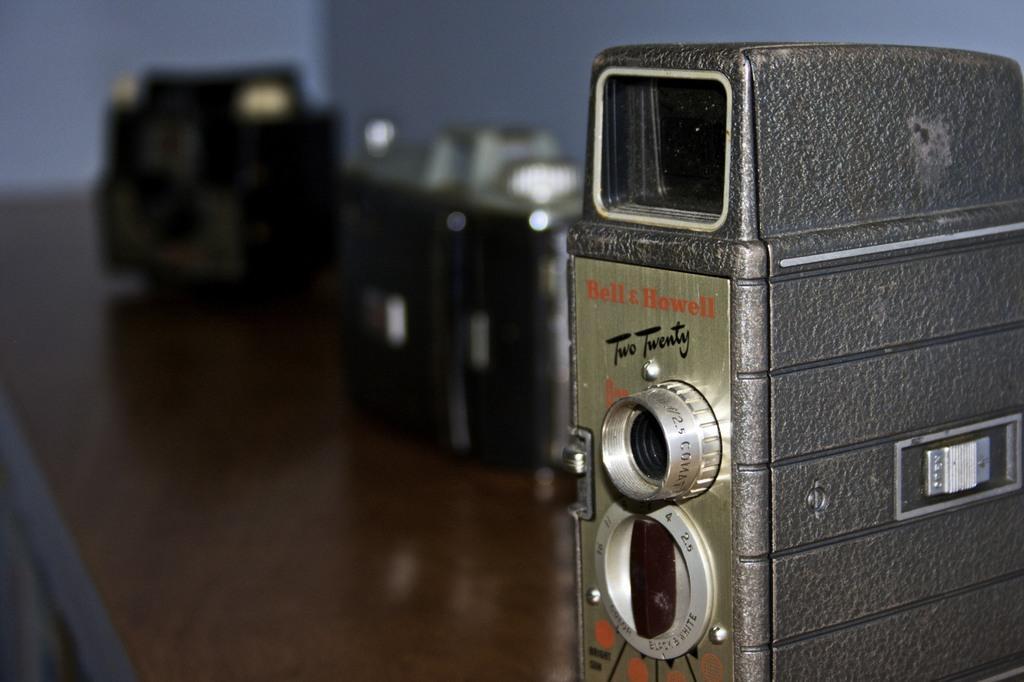In one or two sentences, can you explain what this image depicts? In this image we can see some devices placed on the surface. At the top of the image we can see the wall. 